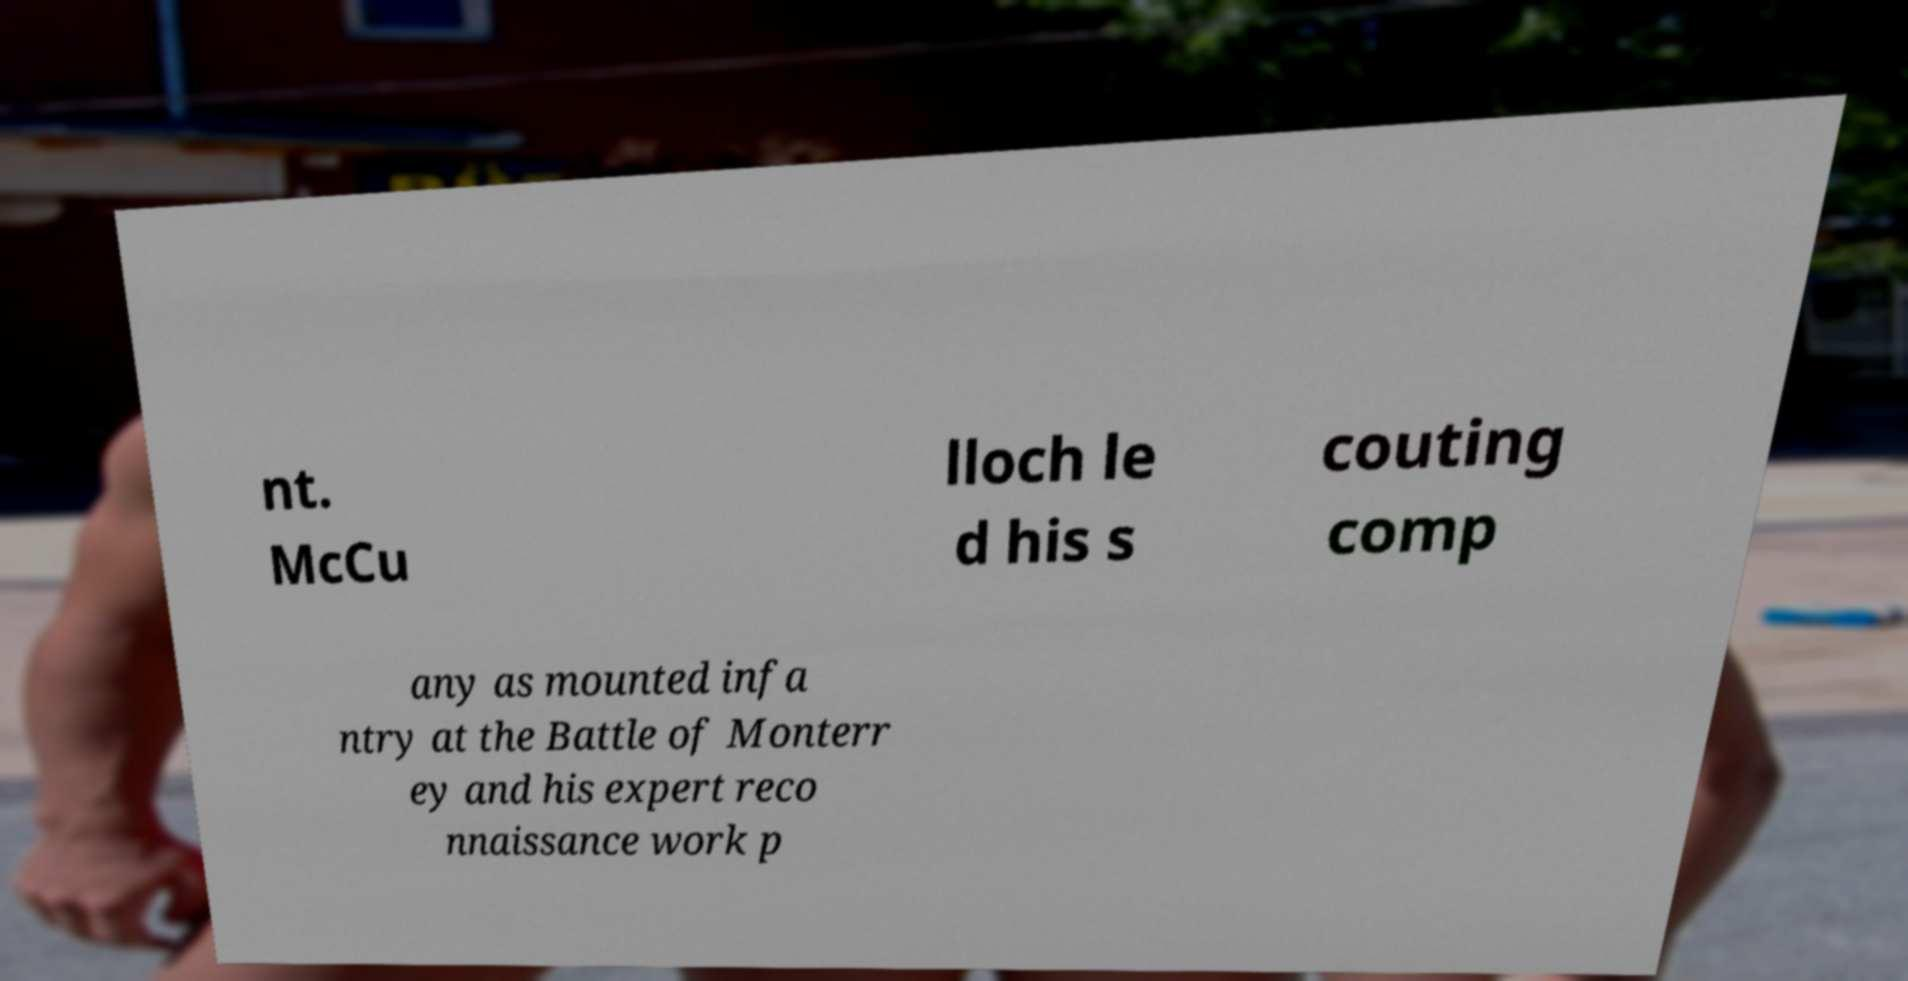For documentation purposes, I need the text within this image transcribed. Could you provide that? nt. McCu lloch le d his s couting comp any as mounted infa ntry at the Battle of Monterr ey and his expert reco nnaissance work p 